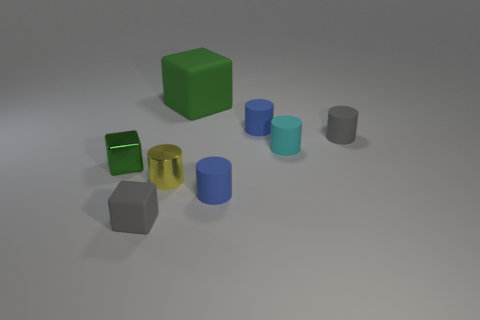What number of big blue rubber objects are there?
Offer a terse response. 0. Are there any yellow metallic blocks that have the same size as the shiny cylinder?
Ensure brevity in your answer.  No. Is the big green cube made of the same material as the gray thing that is on the left side of the big green block?
Offer a terse response. Yes. There is a gray thing to the left of the cyan cylinder; what material is it?
Offer a very short reply. Rubber. The green metallic object has what size?
Offer a terse response. Small. Does the green thing that is on the left side of the yellow cylinder have the same size as the gray matte thing right of the yellow object?
Your response must be concise. Yes. There is a gray object that is the same shape as the large green matte object; what size is it?
Keep it short and to the point. Small. Do the green shiny block and the blue matte thing that is in front of the yellow cylinder have the same size?
Offer a terse response. Yes. Is there a small thing that is behind the small gray matte thing behind the green metal block?
Provide a short and direct response. Yes. What shape is the gray rubber object that is in front of the cyan thing?
Keep it short and to the point. Cube. 